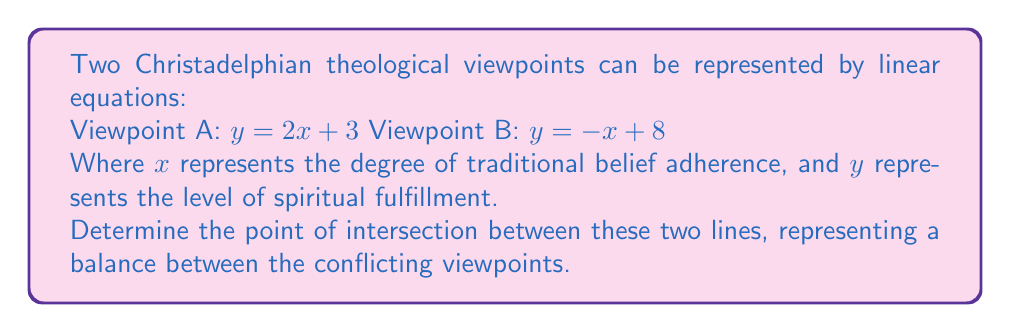Can you solve this math problem? To find the point of intersection, we need to solve the system of equations:

$$\begin{cases}
y = 2x + 3 \\
y = -x + 8
\end{cases}$$

Step 1: Set the two equations equal to each other.
$2x + 3 = -x + 8$

Step 2: Solve for x by adding x to both sides and subtracting 3 from both sides.
$3x = 5$
$x = \frac{5}{3}$

Step 3: Substitute this x-value into either of the original equations. Let's use the first equation:
$y = 2(\frac{5}{3}) + 3$
$y = \frac{10}{3} + 3$
$y = \frac{10}{3} + \frac{9}{3}$
$y = \frac{19}{3}$

Step 4: The point of intersection is $(\frac{5}{3}, \frac{19}{3})$.

This point represents a balance between the two theological viewpoints, where the degree of traditional belief adherence (x) and the level of spiritual fulfillment (y) are in equilibrium for both perspectives.
Answer: $(\frac{5}{3}, \frac{19}{3})$ 